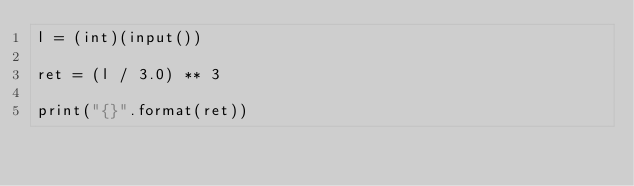Convert code to text. <code><loc_0><loc_0><loc_500><loc_500><_Python_>l = (int)(input())

ret = (l / 3.0) ** 3

print("{}".format(ret))</code> 